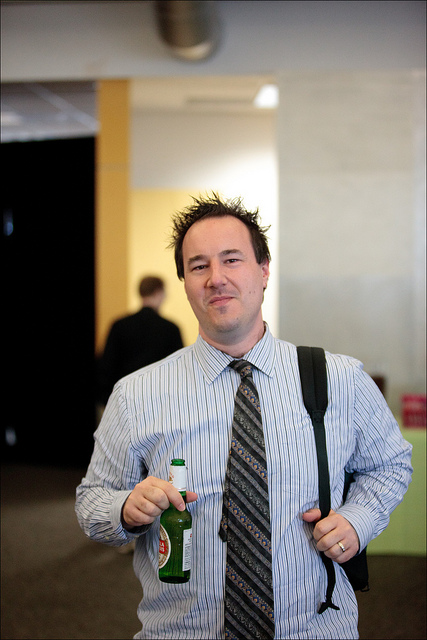<image>Whose tie is more colorful? It's unknown whose tie is more colorful. It could be the man's tie. What floor is the elevator going to? I don't know what floor the elevator is going to. There might not be an elevator in the image. What is the man eating? I am not sure what the man is eating. It seems like he is drinking beer. Whose tie is more colorful? I don't know whose tie is more colorful. There is only one person shown in the image. What floor is the elevator going to? I don't know what floor the elevator is going to. It can be any floor between 1 and 10. What is the man eating? I don't know what the man is eating. But it can be seen that he is drinking beer. 